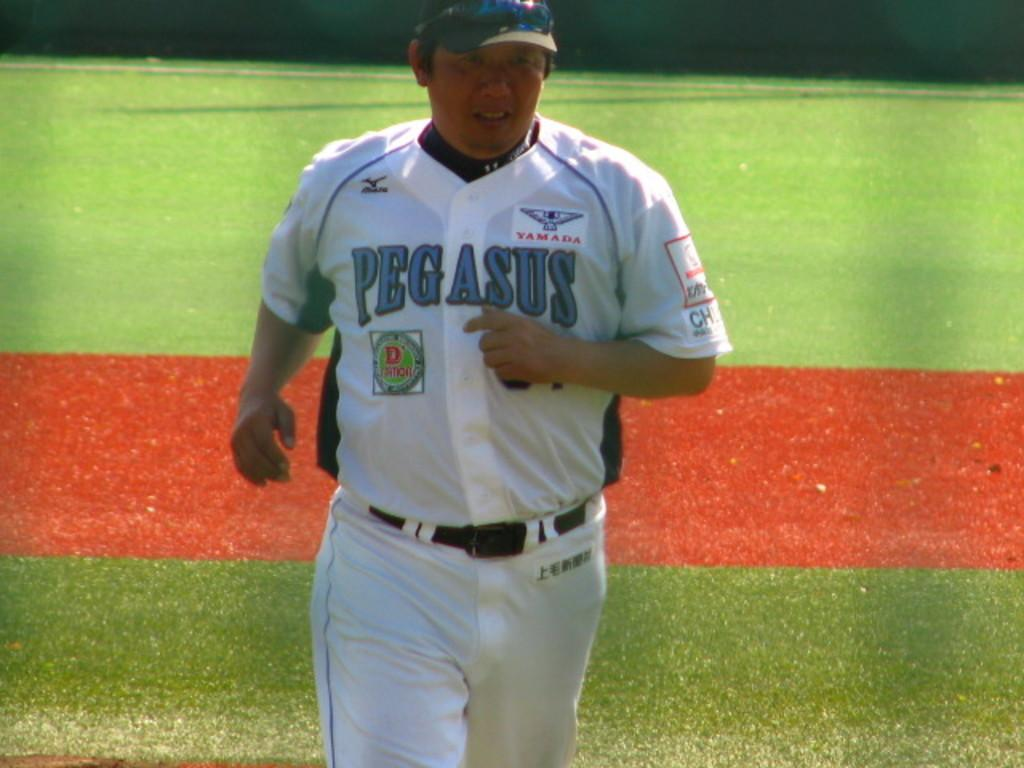Provide a one-sentence caption for the provided image. A Pegasus team member jogs across the field. 